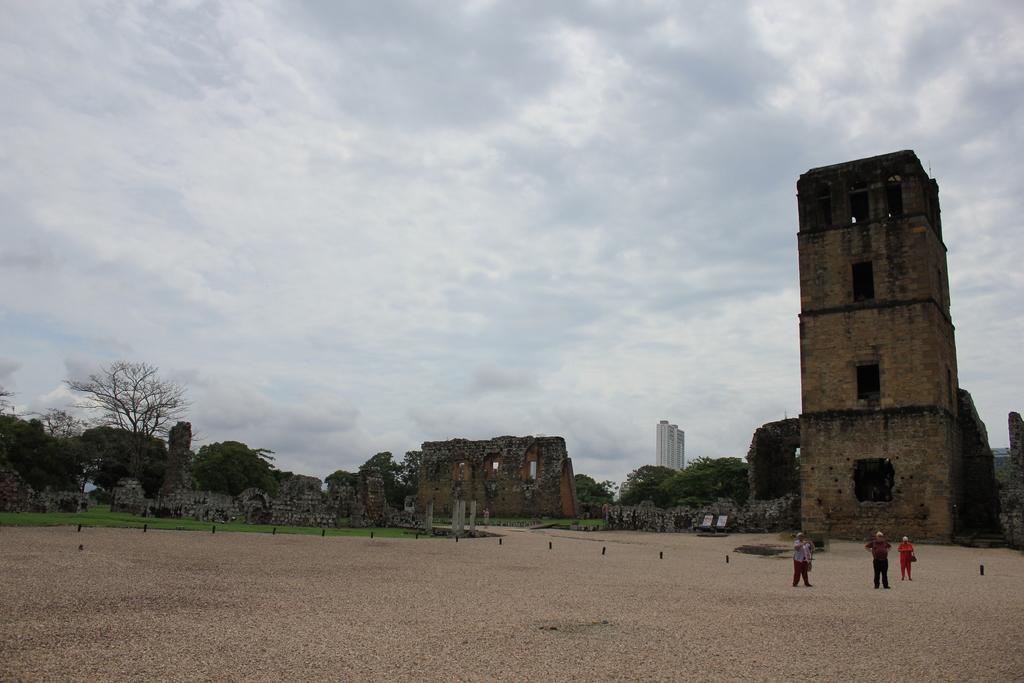Could you give a brief overview of what you see in this image? In this image I can see group of people standing, background I can see few buildings in cream and white color and the sky is in white color. 